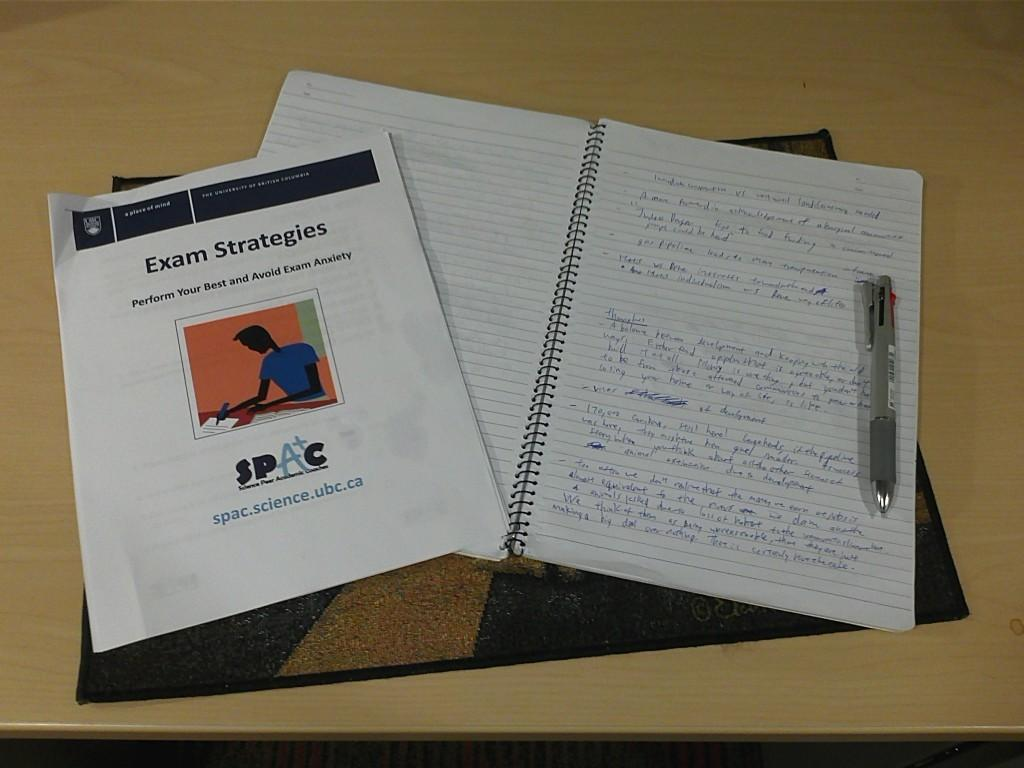<image>
Describe the image concisely. a notebook and pamphlet that says Exam Strategies on it 